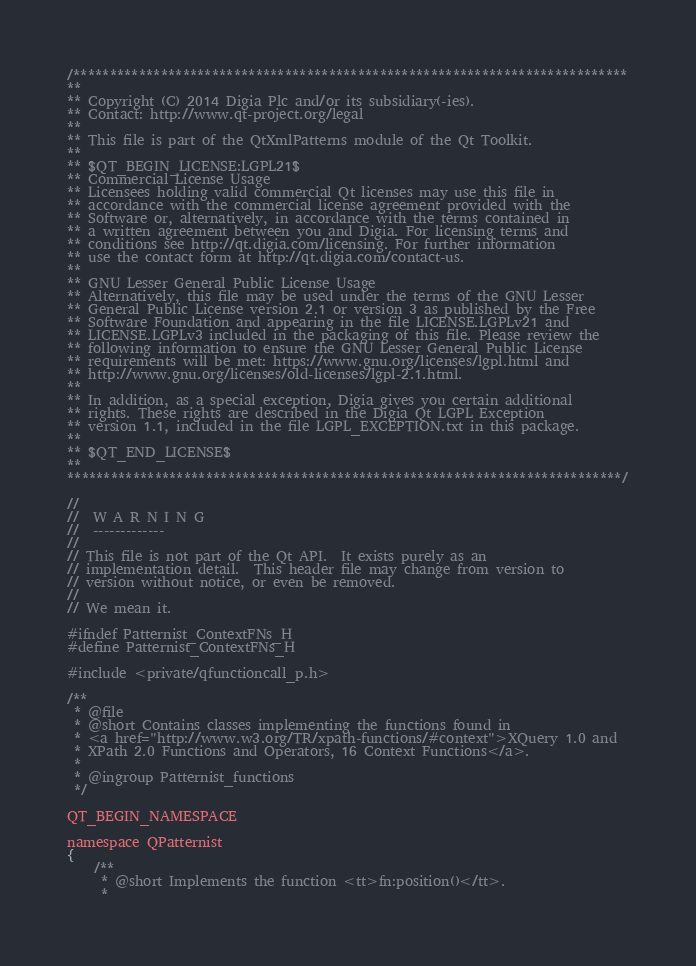Convert code to text. <code><loc_0><loc_0><loc_500><loc_500><_C_>/****************************************************************************
**
** Copyright (C) 2014 Digia Plc and/or its subsidiary(-ies).
** Contact: http://www.qt-project.org/legal
**
** This file is part of the QtXmlPatterns module of the Qt Toolkit.
**
** $QT_BEGIN_LICENSE:LGPL21$
** Commercial License Usage
** Licensees holding valid commercial Qt licenses may use this file in
** accordance with the commercial license agreement provided with the
** Software or, alternatively, in accordance with the terms contained in
** a written agreement between you and Digia. For licensing terms and
** conditions see http://qt.digia.com/licensing. For further information
** use the contact form at http://qt.digia.com/contact-us.
**
** GNU Lesser General Public License Usage
** Alternatively, this file may be used under the terms of the GNU Lesser
** General Public License version 2.1 or version 3 as published by the Free
** Software Foundation and appearing in the file LICENSE.LGPLv21 and
** LICENSE.LGPLv3 included in the packaging of this file. Please review the
** following information to ensure the GNU Lesser General Public License
** requirements will be met: https://www.gnu.org/licenses/lgpl.html and
** http://www.gnu.org/licenses/old-licenses/lgpl-2.1.html.
**
** In addition, as a special exception, Digia gives you certain additional
** rights. These rights are described in the Digia Qt LGPL Exception
** version 1.1, included in the file LGPL_EXCEPTION.txt in this package.
**
** $QT_END_LICENSE$
**
****************************************************************************/

//
//  W A R N I N G
//  -------------
//
// This file is not part of the Qt API.  It exists purely as an
// implementation detail.  This header file may change from version to
// version without notice, or even be removed.
//
// We mean it.

#ifndef Patternist_ContextFNs_H
#define Patternist_ContextFNs_H

#include <private/qfunctioncall_p.h>

/**
 * @file
 * @short Contains classes implementing the functions found in
 * <a href="http://www.w3.org/TR/xpath-functions/#context">XQuery 1.0 and
 * XPath 2.0 Functions and Operators, 16 Context Functions</a>.
 *
 * @ingroup Patternist_functions
 */

QT_BEGIN_NAMESPACE

namespace QPatternist
{
    /**
     * @short Implements the function <tt>fn:position()</tt>.
     *</code> 